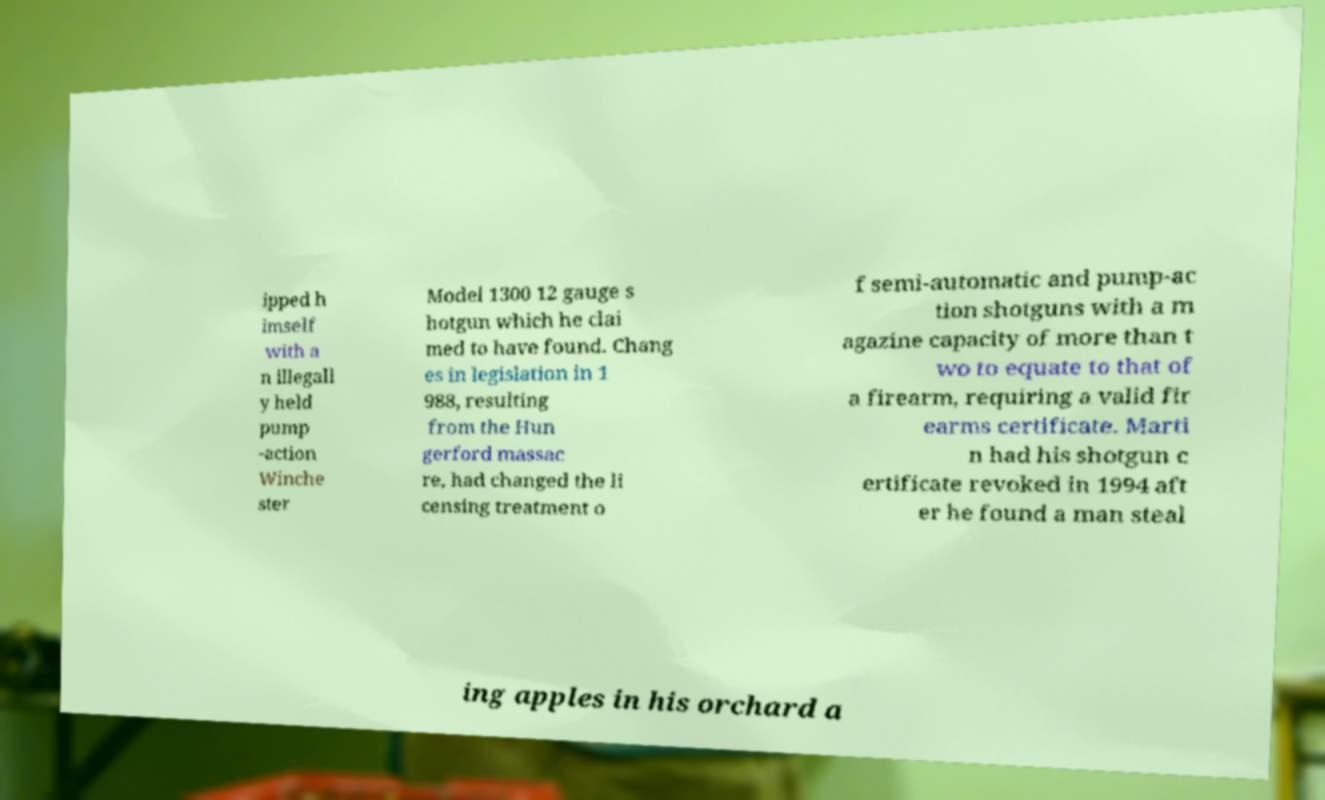Can you read and provide the text displayed in the image?This photo seems to have some interesting text. Can you extract and type it out for me? ipped h imself with a n illegall y held pump -action Winche ster Model 1300 12 gauge s hotgun which he clai med to have found. Chang es in legislation in 1 988, resulting from the Hun gerford massac re, had changed the li censing treatment o f semi-automatic and pump-ac tion shotguns with a m agazine capacity of more than t wo to equate to that of a firearm, requiring a valid fir earms certificate. Marti n had his shotgun c ertificate revoked in 1994 aft er he found a man steal ing apples in his orchard a 